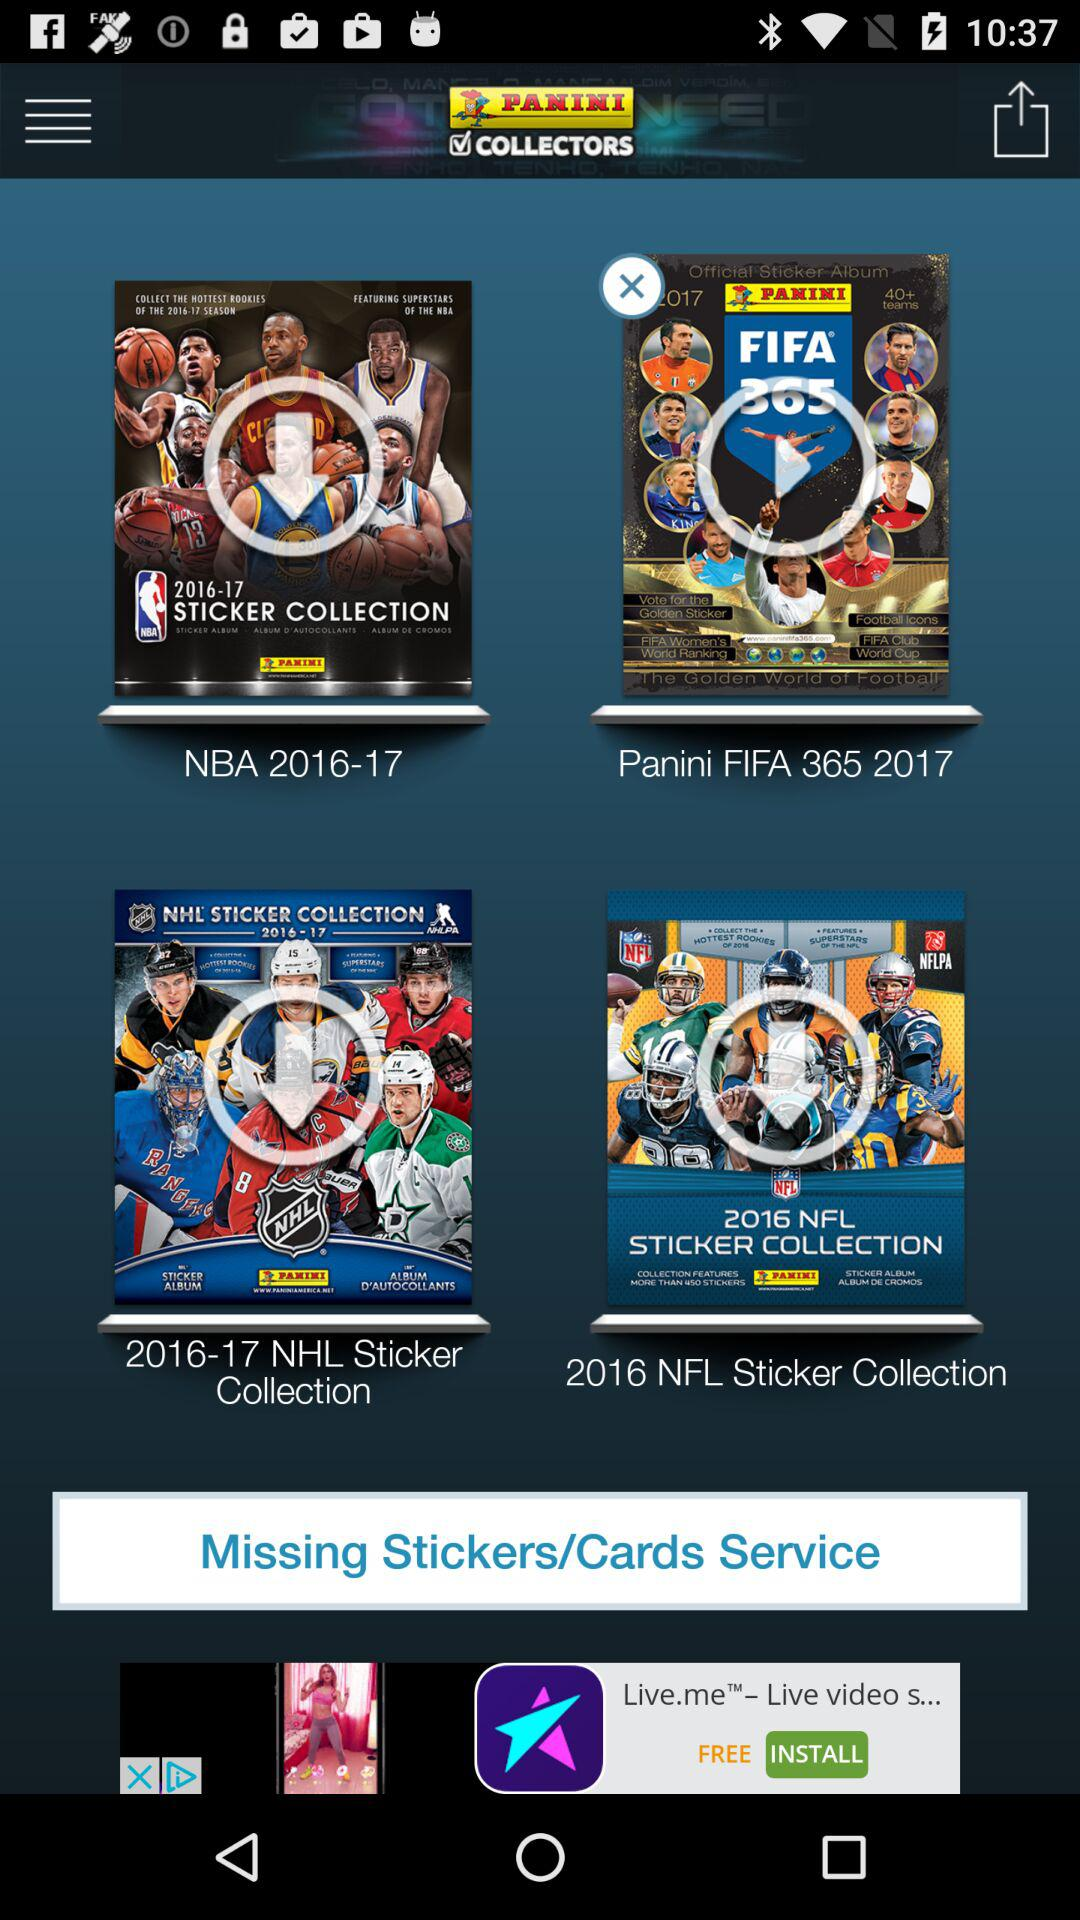What is the season of the NBA? The season of the NBA is 2016-17. 